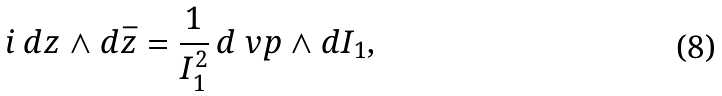Convert formula to latex. <formula><loc_0><loc_0><loc_500><loc_500>i \, d z \wedge d \bar { z } = \frac { 1 } { I _ { 1 } ^ { 2 } } \, d \ v p \wedge d I _ { 1 } ,</formula> 